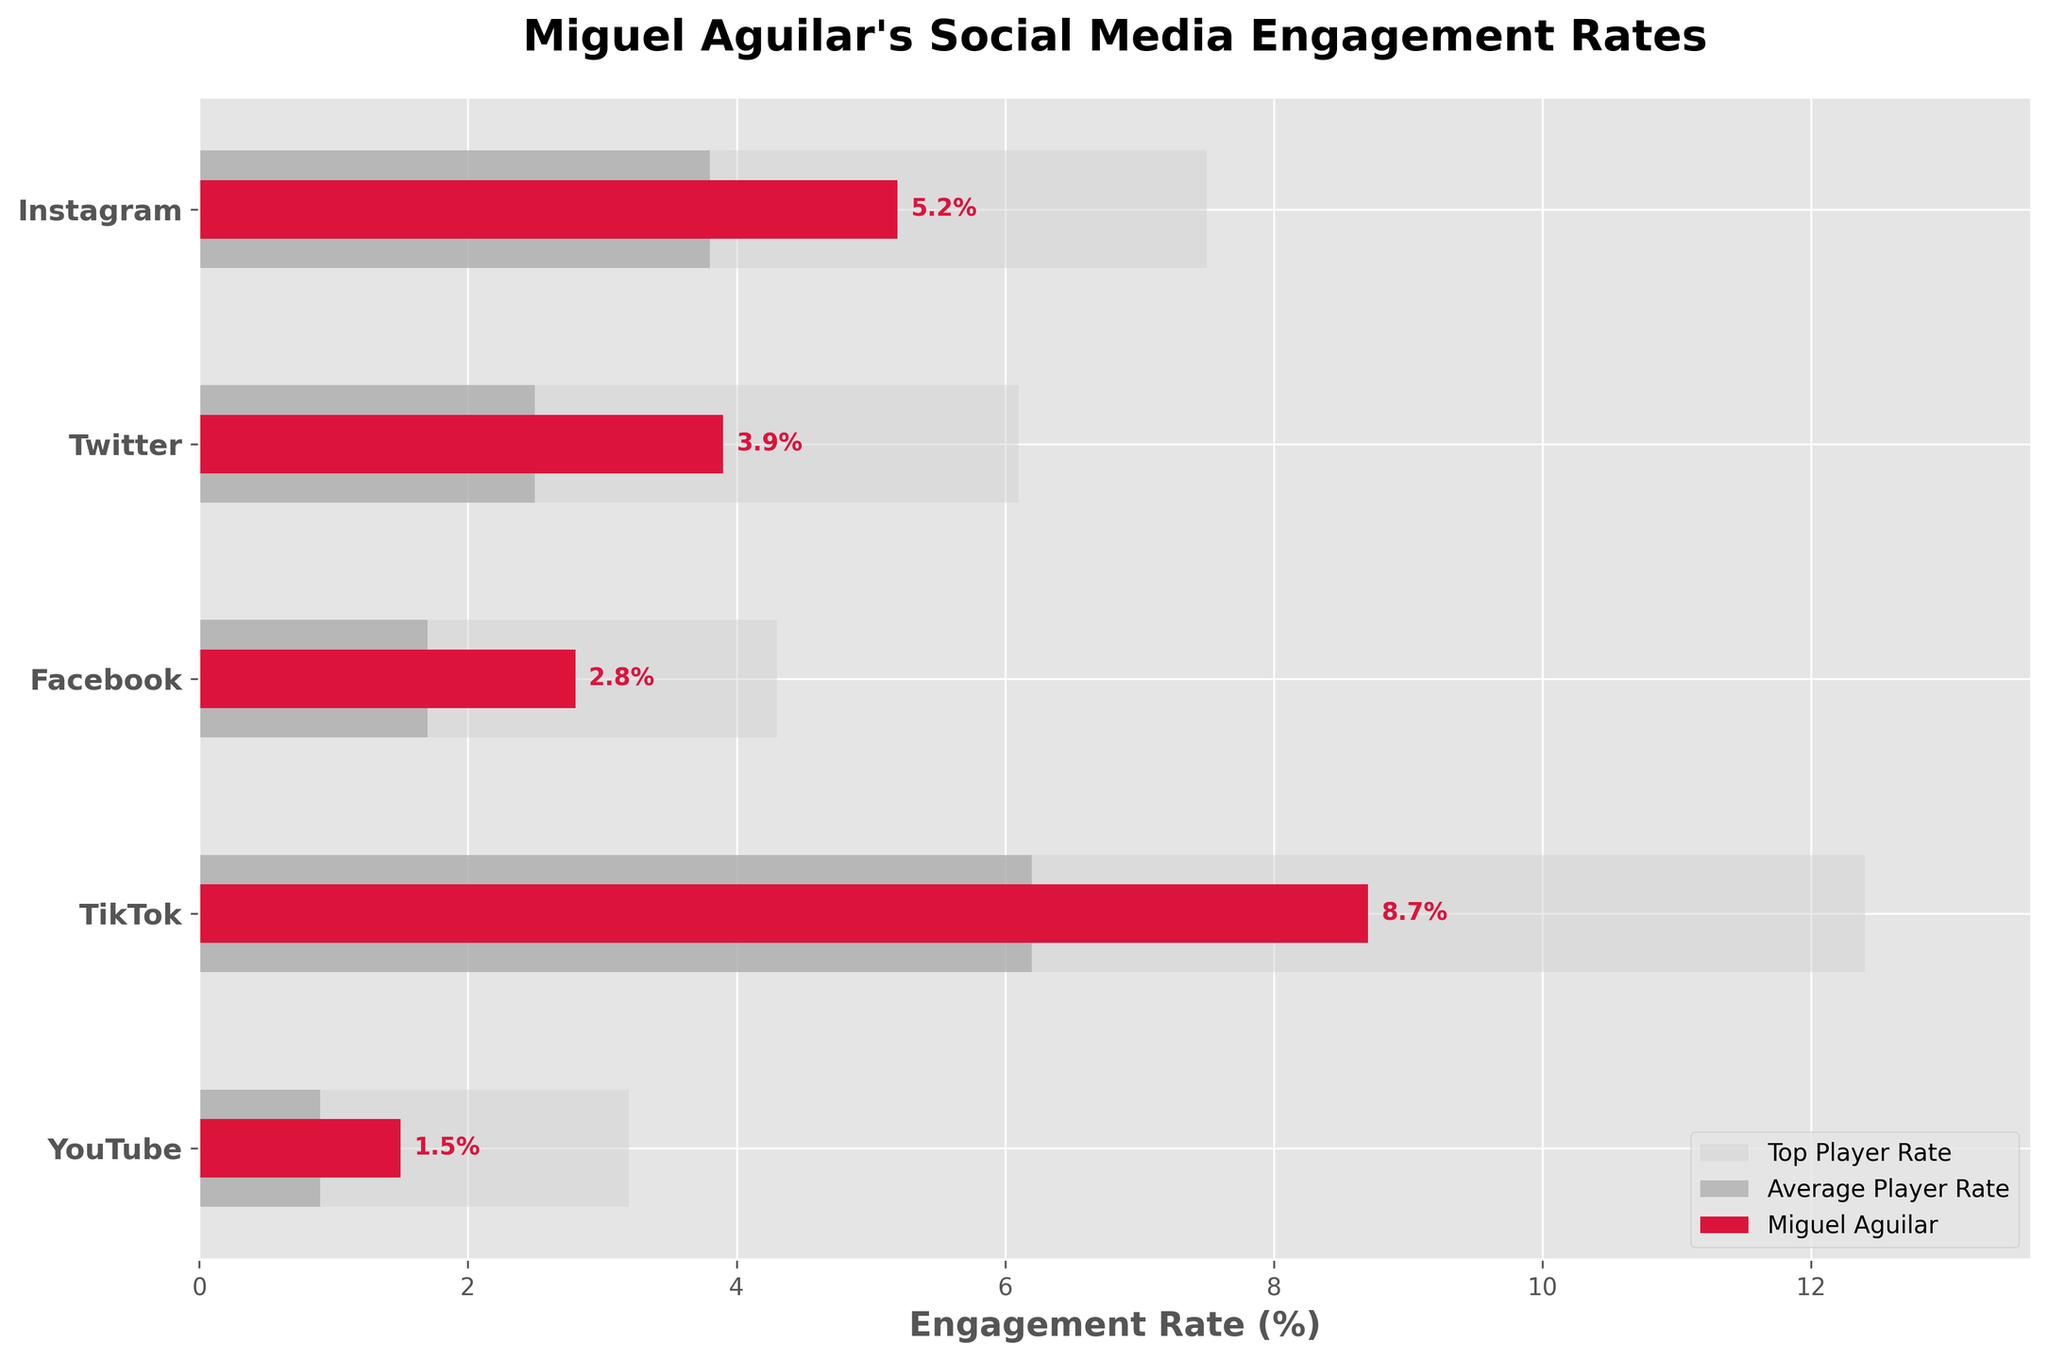Which platform has the highest engagement rate for Miguel Aguilar? According to the figure, TikTok has the highest engagement rate for Miguel Aguilar.
Answer: TikTok Which platform has the lowest engagement rate for the average player? The figure shows that YouTube has the lowest engagement rate for the average player.
Answer: YouTube How does Miguel Aguilar's engagement rate on Instagram compare to the average player's rate on the same platform? Comparing the bars, Miguel Aguilar's engagement rate on Instagram (5.2%) is higher than the average player's engagement rate on Instagram (3.8%).
Answer: Higher What's the difference between Miguel Aguilar's engagement rate and the top player's engagement rate on Facebook? Miguel Aguilar's engagement rate on Facebook is 2.8% and the top player's engagement rate is 4.3%. The difference is 4.3% - 2.8% = 1.5%.
Answer: 1.5% Which platform has the smallest gap between Miguel Aguilar's engagement rate and the top player's engagement rate? Observing the figure, YouTube has the smallest gap, with Miguel Aguilar at 1.5% and the top player at 3.2%, resulting in a difference of 1.7%.
Answer: YouTube On which platform does Miguel Aguilar's engagement rate most closely match the top player's engagement rate? Comparing all the platforms, the closest match is on Facebook where Miguel Aguilar's engagement rate is 2.8% and the top player's rate is 4.3%. The difference is 1.5%.
Answer: Facebook If we average Miguel Aguilar’s engagement rates across all platforms, what is the result? Adding up Miguel Aguilar’s rates: 5.2 + 3.9 + 2.8 + 8.7 + 1.5, we get 22.1. Dividing by the number of platforms (5), the average is 22.1 / 5 = 4.42%.
Answer: 4.42% How much higher is Miguel Aguilar's engagement rate on TikTok compared to the average player's engagement rate on TikTok? Miguel Aguilar’s rate on TikTok is 8.7% and the average player’s rate is 6.2%. The difference is 8.7% - 6.2% = 2.5%.
Answer: 2.5% Which platform shows the largest difference between the top player's engagement rate and the average player's engagement rate? The figure shows that the largest difference is on TikTok, where the top player's rate is 12.4% and the average player's rate is 6.2%, resulting in a difference of 6.2%.
Answer: TikTok 